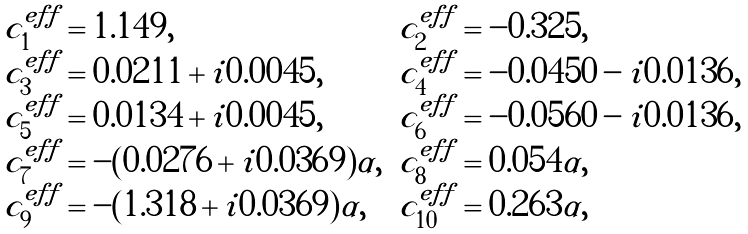<formula> <loc_0><loc_0><loc_500><loc_500>\begin{array} { l l } c ^ { e f f } _ { 1 } = 1 . 1 4 9 , & c ^ { e f f } _ { 2 } = - 0 . 3 2 5 , \\ c ^ { e f f } _ { 3 } = 0 . 0 2 1 1 + i 0 . 0 0 4 5 , & c ^ { e f f } _ { 4 } = - 0 . 0 4 5 0 - i 0 . 0 1 3 6 , \\ c ^ { e f f } _ { 5 } = 0 . 0 1 3 4 + i 0 . 0 0 4 5 , & c ^ { e f f } _ { 6 } = - 0 . 0 5 6 0 - i 0 . 0 1 3 6 , \\ c ^ { e f f } _ { 7 } = - ( 0 . 0 2 7 6 + i 0 . 0 3 6 9 ) \alpha , & c ^ { e f f } _ { 8 } = 0 . 0 5 4 \alpha , \\ c ^ { e f f } _ { 9 } = - ( 1 . 3 1 8 + i 0 . 0 3 6 9 ) \alpha , & c ^ { e f f } _ { 1 0 } = 0 . 2 6 3 \alpha , \end{array}</formula> 